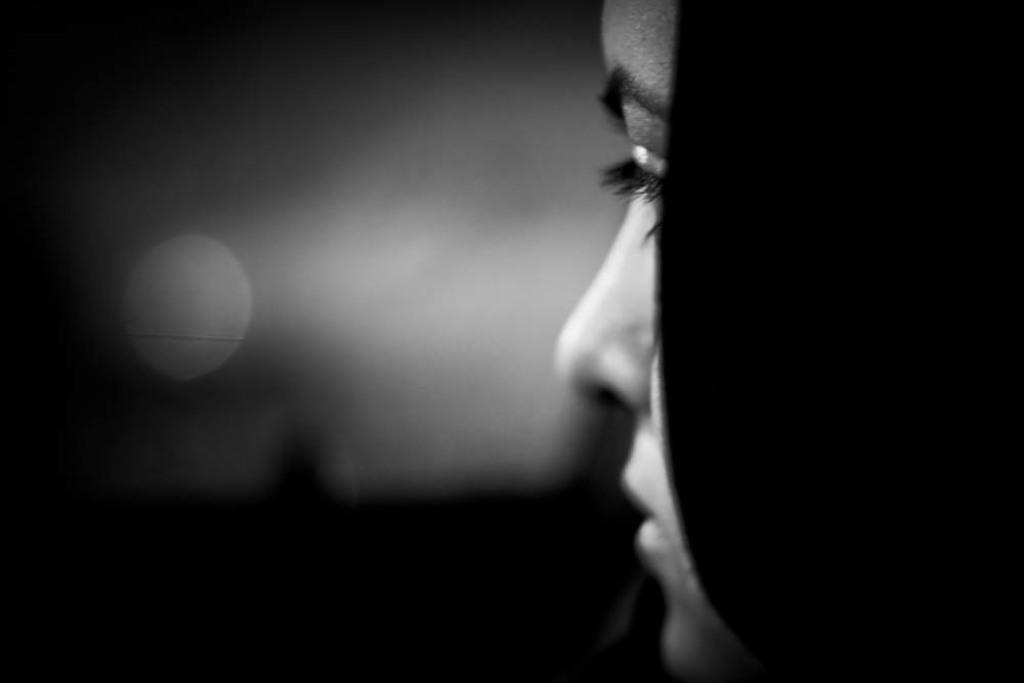How would you summarize this image in a sentence or two? This is black and white picture of a girl. 